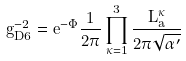<formula> <loc_0><loc_0><loc_500><loc_500>g ^ { - 2 } _ { D 6 } = e ^ { - \Phi } \frac { 1 } { 2 \pi } \prod _ { \kappa = 1 } ^ { 3 } \frac { L _ { a } ^ { \kappa } } { 2 \pi \sqrt { \alpha ^ { \prime } } }</formula> 